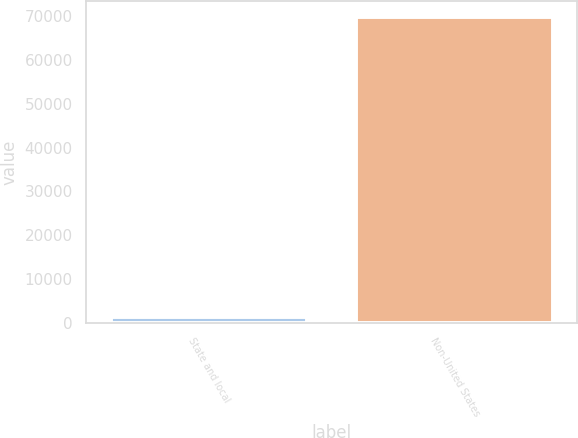Convert chart. <chart><loc_0><loc_0><loc_500><loc_500><bar_chart><fcel>State and local<fcel>Non-United States<nl><fcel>1402<fcel>69905<nl></chart> 